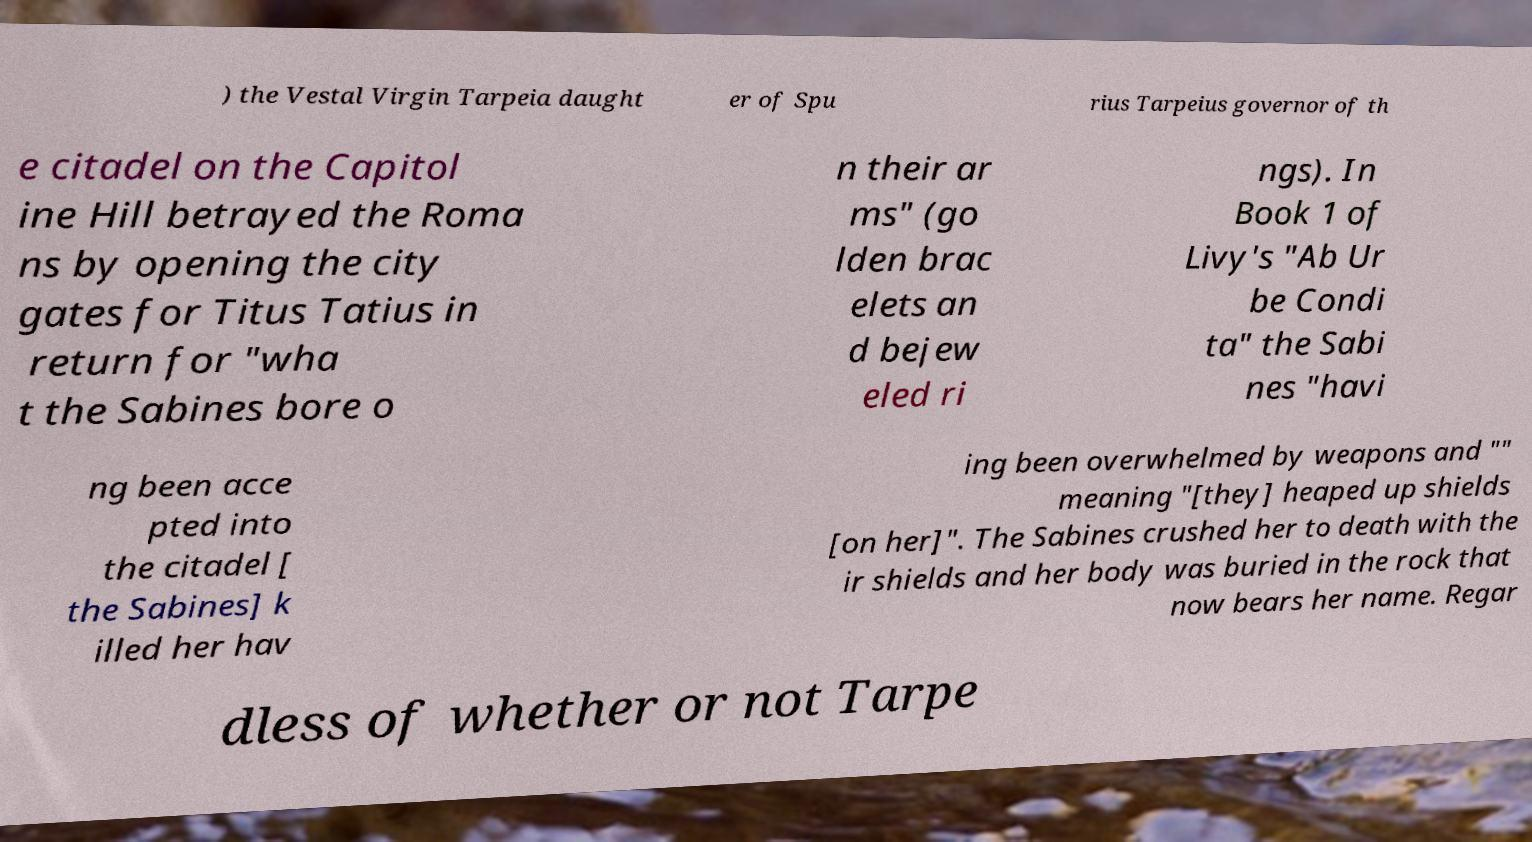There's text embedded in this image that I need extracted. Can you transcribe it verbatim? ) the Vestal Virgin Tarpeia daught er of Spu rius Tarpeius governor of th e citadel on the Capitol ine Hill betrayed the Roma ns by opening the city gates for Titus Tatius in return for "wha t the Sabines bore o n their ar ms" (go lden brac elets an d bejew eled ri ngs). In Book 1 of Livy's "Ab Ur be Condi ta" the Sabi nes "havi ng been acce pted into the citadel [ the Sabines] k illed her hav ing been overwhelmed by weapons and "" meaning "[they] heaped up shields [on her]". The Sabines crushed her to death with the ir shields and her body was buried in the rock that now bears her name. Regar dless of whether or not Tarpe 